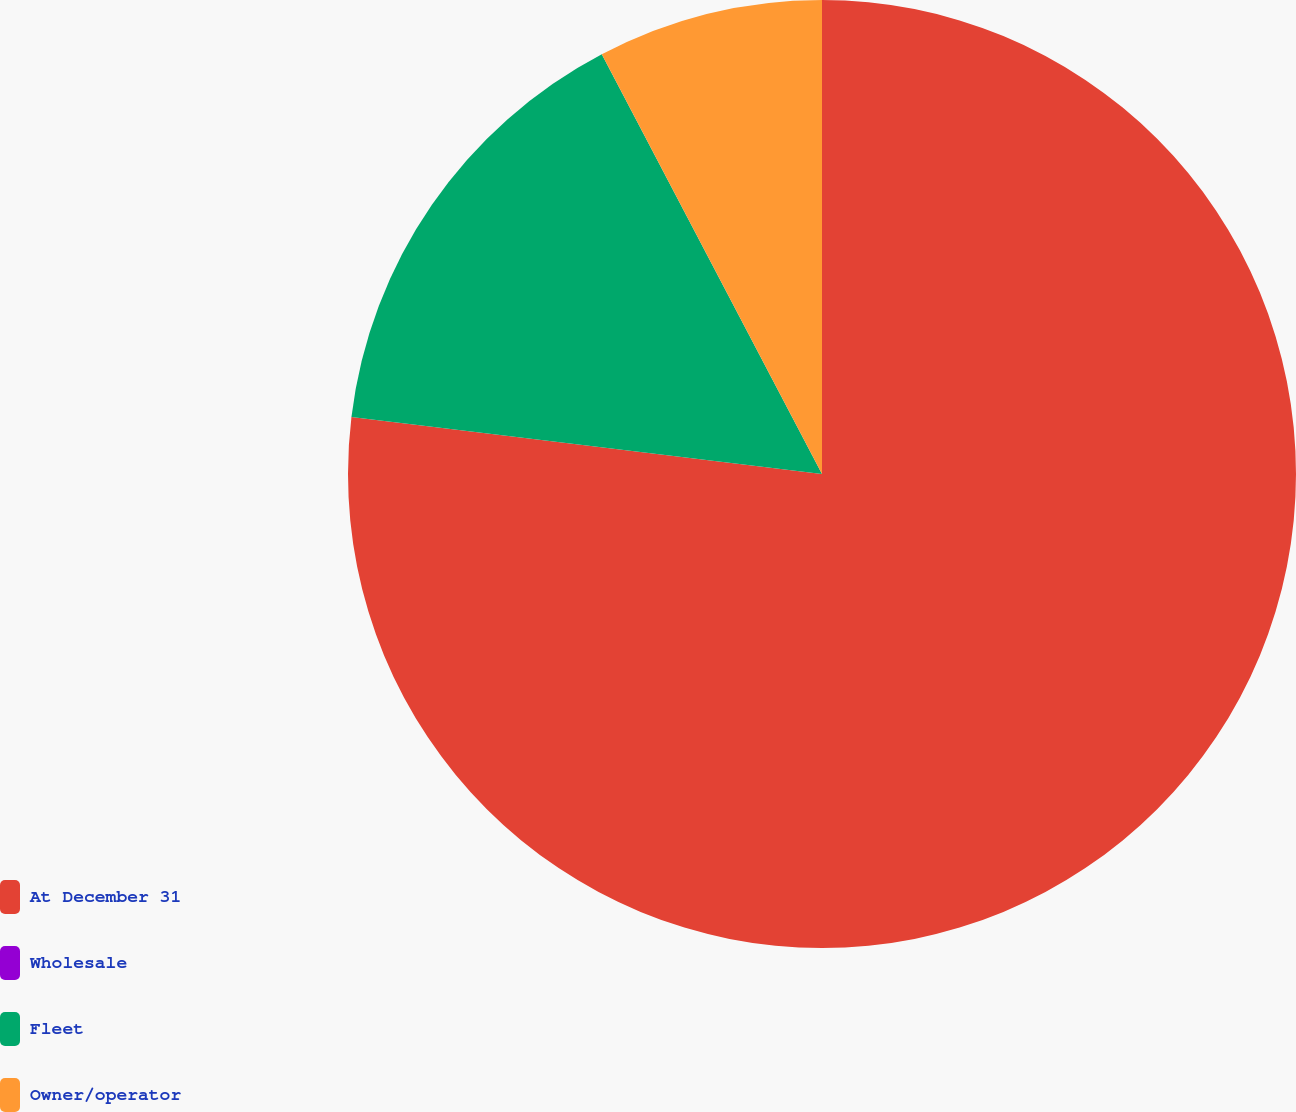Convert chart. <chart><loc_0><loc_0><loc_500><loc_500><pie_chart><fcel>At December 31<fcel>Wholesale<fcel>Fleet<fcel>Owner/operator<nl><fcel>76.92%<fcel>0.0%<fcel>15.39%<fcel>7.69%<nl></chart> 